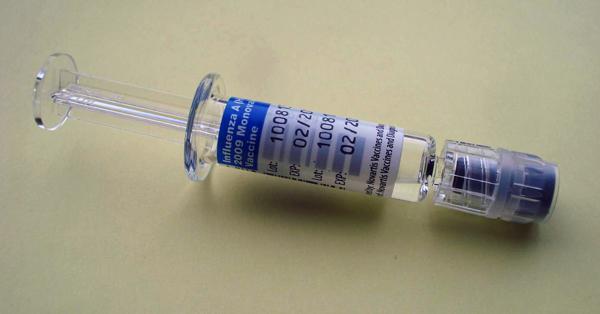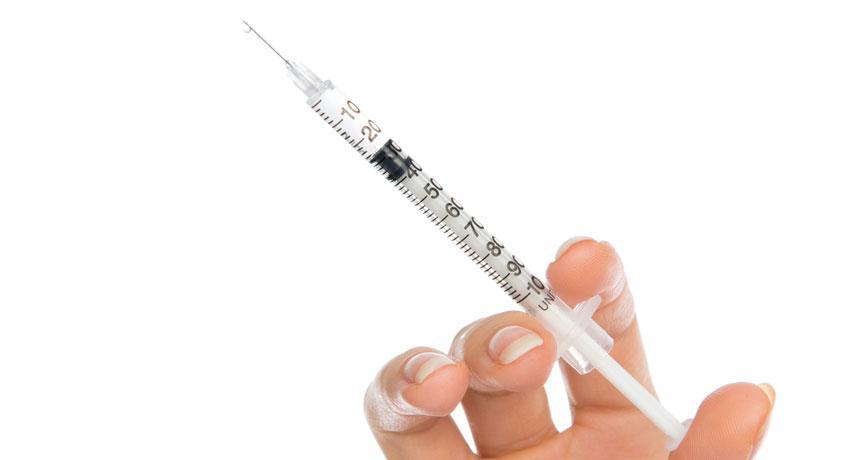The first image is the image on the left, the second image is the image on the right. Given the left and right images, does the statement "There are more syringes in the image on the right." hold true? Answer yes or no. No. The first image is the image on the left, the second image is the image on the right. For the images displayed, is the sentence "The right image includes more syringe-type tubes than the left image." factually correct? Answer yes or no. No. 